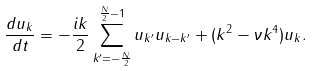Convert formula to latex. <formula><loc_0><loc_0><loc_500><loc_500>\frac { d u _ { k } } { d t } = - \frac { i k } { 2 } \sum _ { k ^ { \prime } = - \frac { N } { 2 } } ^ { \frac { N } { 2 } - 1 } { u } _ { k ^ { \prime } } { u } _ { k - k ^ { \prime } } + ( k ^ { 2 } - \nu k ^ { 4 } ) u _ { k } .</formula> 